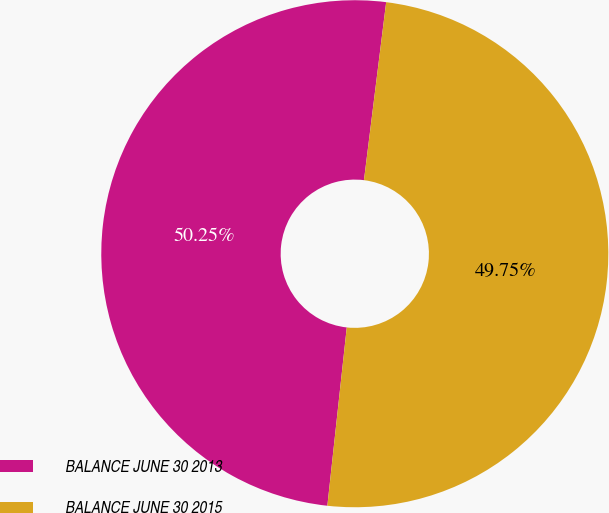Convert chart to OTSL. <chart><loc_0><loc_0><loc_500><loc_500><pie_chart><fcel>BALANCE JUNE 30 2013<fcel>BALANCE JUNE 30 2015<nl><fcel>50.25%<fcel>49.75%<nl></chart> 